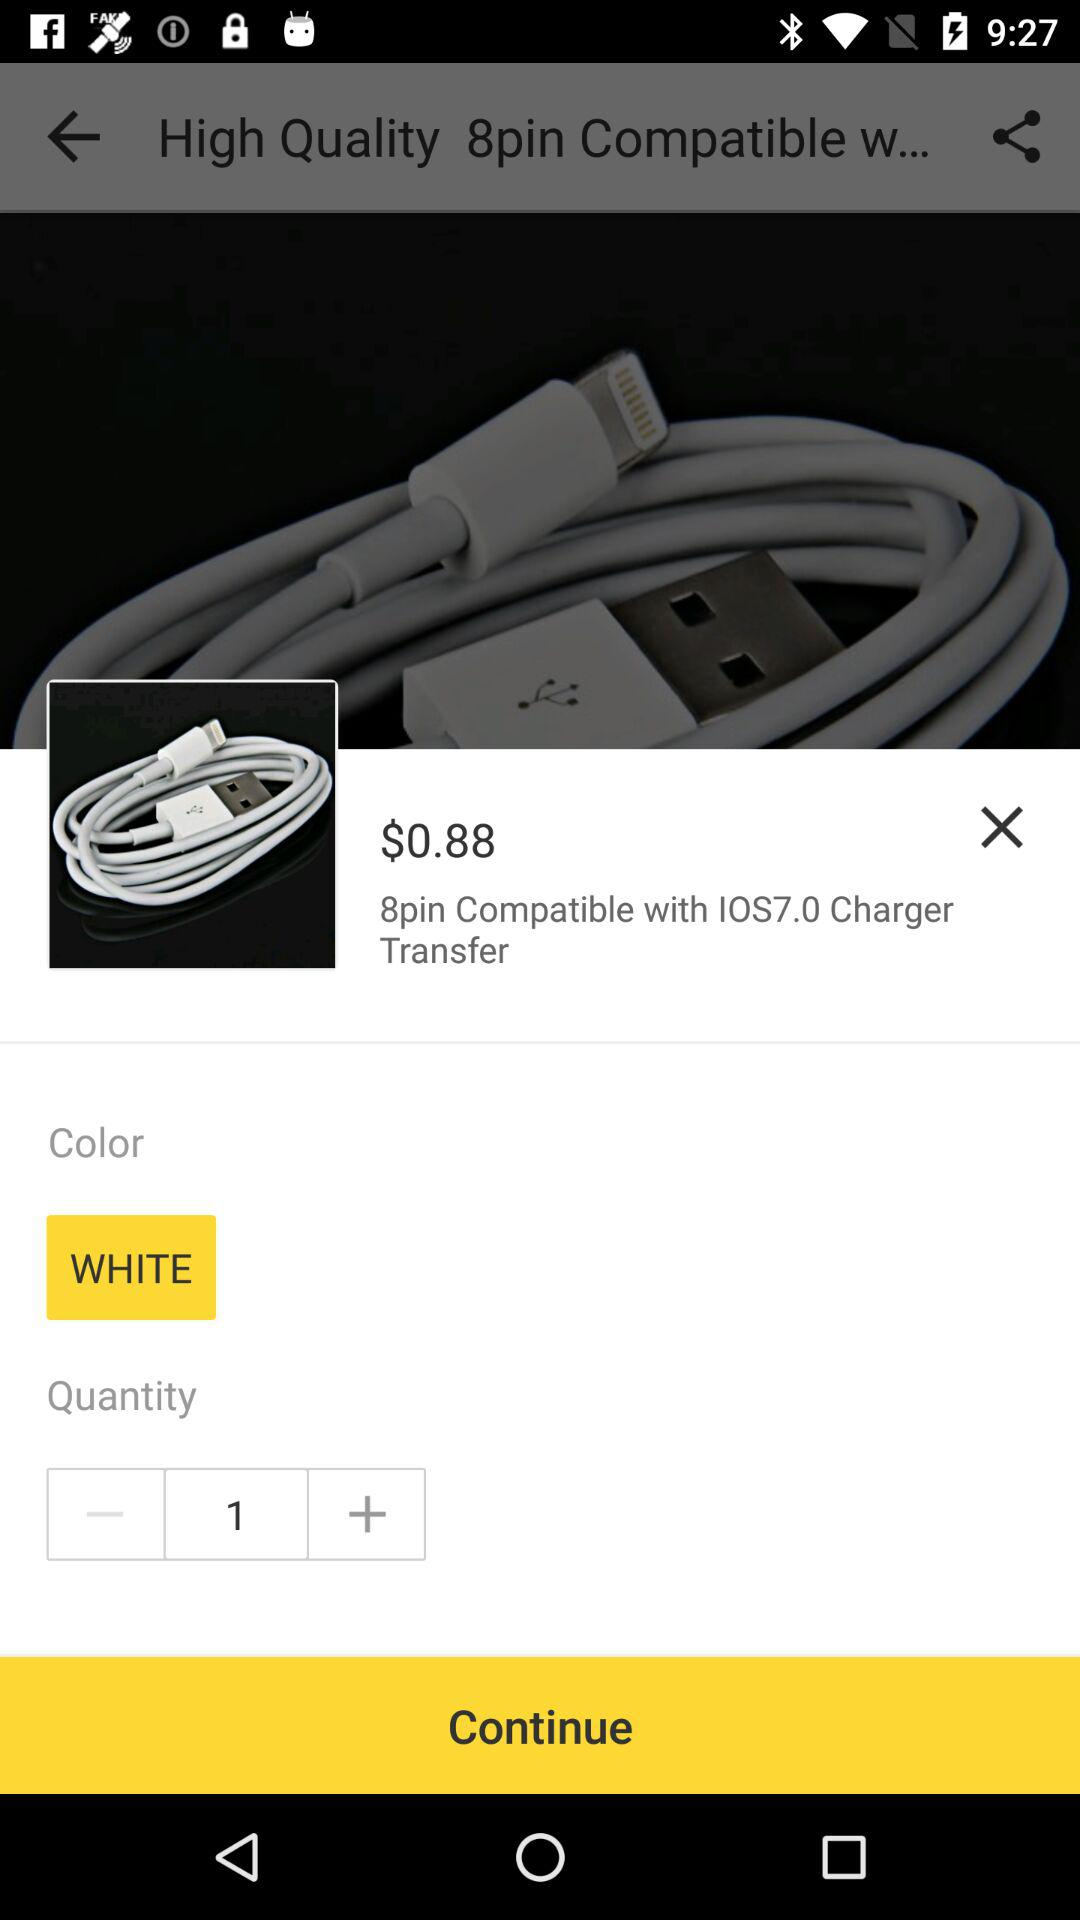How many items are in the cart?
Answer the question using a single word or phrase. 1 